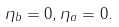Convert formula to latex. <formula><loc_0><loc_0><loc_500><loc_500>\eta _ { b } = 0 , \eta _ { a } = 0 .</formula> 